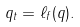Convert formula to latex. <formula><loc_0><loc_0><loc_500><loc_500>q _ { t } = \ell _ { f } ( q ) .</formula> 